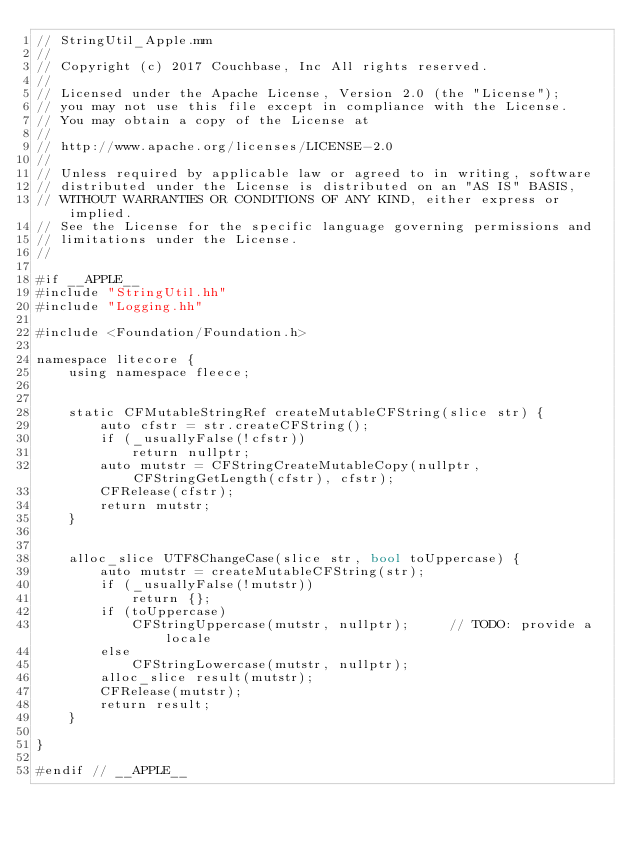<code> <loc_0><loc_0><loc_500><loc_500><_ObjectiveC_>// StringUtil_Apple.mm
//
// Copyright (c) 2017 Couchbase, Inc All rights reserved.
//
// Licensed under the Apache License, Version 2.0 (the "License");
// you may not use this file except in compliance with the License.
// You may obtain a copy of the License at
//
// http://www.apache.org/licenses/LICENSE-2.0
//
// Unless required by applicable law or agreed to in writing, software
// distributed under the License is distributed on an "AS IS" BASIS,
// WITHOUT WARRANTIES OR CONDITIONS OF ANY KIND, either express or implied.
// See the License for the specific language governing permissions and
// limitations under the License.
//

#if __APPLE__
#include "StringUtil.hh"
#include "Logging.hh"

#include <Foundation/Foundation.h>

namespace litecore {
    using namespace fleece;


    static CFMutableStringRef createMutableCFString(slice str) {
        auto cfstr = str.createCFString();
        if (_usuallyFalse(!cfstr))
            return nullptr;
        auto mutstr = CFStringCreateMutableCopy(nullptr, CFStringGetLength(cfstr), cfstr);
        CFRelease(cfstr);
        return mutstr;
    }


    alloc_slice UTF8ChangeCase(slice str, bool toUppercase) {
        auto mutstr = createMutableCFString(str);
        if (_usuallyFalse(!mutstr))
            return {};
        if (toUppercase)
            CFStringUppercase(mutstr, nullptr);     // TODO: provide a locale
        else
            CFStringLowercase(mutstr, nullptr);
        alloc_slice result(mutstr);
        CFRelease(mutstr);
        return result;
    }

}

#endif // __APPLE__
</code> 